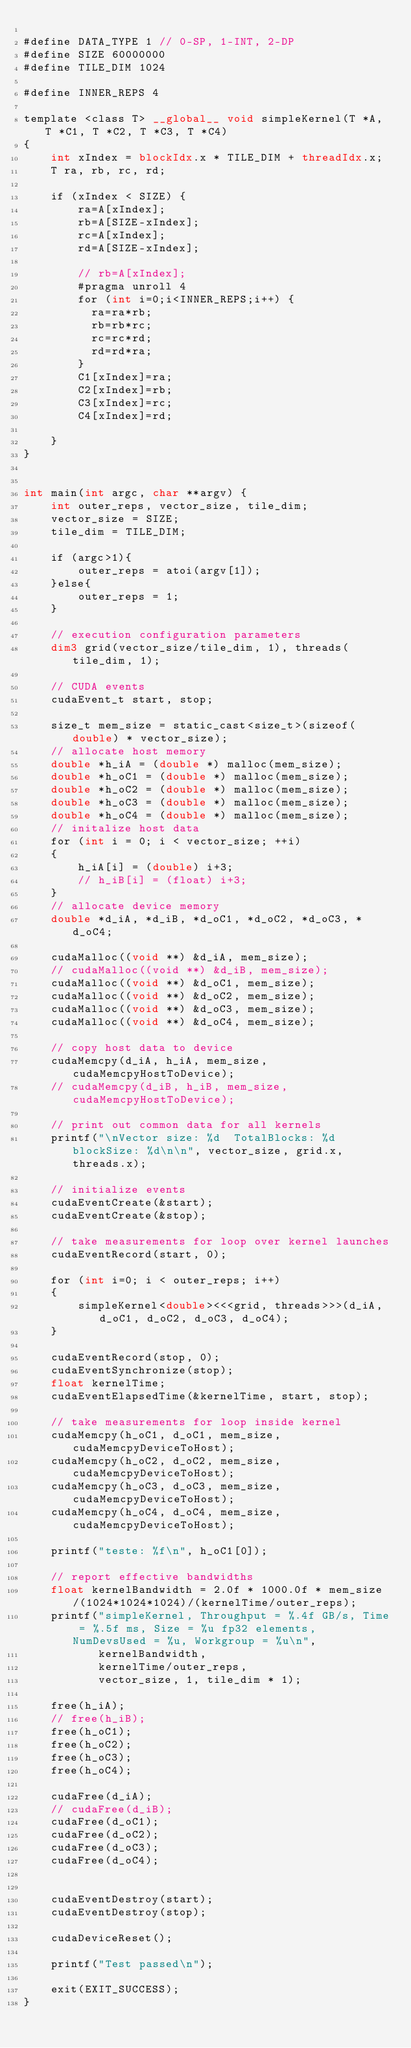<code> <loc_0><loc_0><loc_500><loc_500><_Cuda_>
#define DATA_TYPE 1 // 0-SP, 1-INT, 2-DP
#define SIZE 60000000
#define TILE_DIM 1024

#define INNER_REPS 4

template <class T> __global__ void simpleKernel(T *A, T *C1, T *C2, T *C3, T *C4)
{
    int xIndex = blockIdx.x * TILE_DIM + threadIdx.x;
    T ra, rb, rc, rd;

    if (xIndex < SIZE) {
        ra=A[xIndex];
        rb=A[SIZE-xIndex];
        rc=A[xIndex];
        rd=A[SIZE-xIndex];

        // rb=A[xIndex];
        #pragma unroll 4
        for (int i=0;i<INNER_REPS;i++) {
          ra=ra*rb;
          rb=rb*rc;
          rc=rc*rd;
          rd=rd*ra;
        }
        C1[xIndex]=ra;
        C2[xIndex]=rb;
        C3[xIndex]=rc;
        C4[xIndex]=rd;

    }
}


int main(int argc, char **argv) {
    int outer_reps, vector_size, tile_dim;
    vector_size = SIZE;
    tile_dim = TILE_DIM;

    if (argc>1){
        outer_reps = atoi(argv[1]);
    }else{
        outer_reps = 1;
    }

    // execution configuration parameters
    dim3 grid(vector_size/tile_dim, 1), threads(tile_dim, 1);

    // CUDA events
    cudaEvent_t start, stop;

    size_t mem_size = static_cast<size_t>(sizeof(double) * vector_size);
    // allocate host memory
    double *h_iA = (double *) malloc(mem_size);
    double *h_oC1 = (double *) malloc(mem_size);
    double *h_oC2 = (double *) malloc(mem_size);
    double *h_oC3 = (double *) malloc(mem_size);
    double *h_oC4 = (double *) malloc(mem_size);
    // initalize host data
    for (int i = 0; i < vector_size; ++i)
    {
        h_iA[i] = (double) i+3;
        // h_iB[i] = (float) i+3;
    }
    // allocate device memory
    double *d_iA, *d_iB, *d_oC1, *d_oC2, *d_oC3, *d_oC4;

    cudaMalloc((void **) &d_iA, mem_size);
    // cudaMalloc((void **) &d_iB, mem_size);
    cudaMalloc((void **) &d_oC1, mem_size);
    cudaMalloc((void **) &d_oC2, mem_size);
    cudaMalloc((void **) &d_oC3, mem_size);
    cudaMalloc((void **) &d_oC4, mem_size);

    // copy host data to device
    cudaMemcpy(d_iA, h_iA, mem_size, cudaMemcpyHostToDevice);
    // cudaMemcpy(d_iB, h_iB, mem_size, cudaMemcpyHostToDevice);

    // print out common data for all kernels
    printf("\nVector size: %d  TotalBlocks: %d blockSize: %d\n\n", vector_size, grid.x, threads.x);

    // initialize events
    cudaEventCreate(&start);
    cudaEventCreate(&stop);

    // take measurements for loop over kernel launches
    cudaEventRecord(start, 0);

    for (int i=0; i < outer_reps; i++)
    {
        simpleKernel<double><<<grid, threads>>>(d_iA, d_oC1, d_oC2, d_oC3, d_oC4);
    }

    cudaEventRecord(stop, 0);
    cudaEventSynchronize(stop);
    float kernelTime;
    cudaEventElapsedTime(&kernelTime, start, stop);

    // take measurements for loop inside kernel
    cudaMemcpy(h_oC1, d_oC1, mem_size, cudaMemcpyDeviceToHost);
    cudaMemcpy(h_oC2, d_oC2, mem_size, cudaMemcpyDeviceToHost);
    cudaMemcpy(h_oC3, d_oC3, mem_size, cudaMemcpyDeviceToHost);
    cudaMemcpy(h_oC4, d_oC4, mem_size, cudaMemcpyDeviceToHost);

    printf("teste: %f\n", h_oC1[0]);

    // report effective bandwidths
    float kernelBandwidth = 2.0f * 1000.0f * mem_size/(1024*1024*1024)/(kernelTime/outer_reps);
    printf("simpleKernel, Throughput = %.4f GB/s, Time = %.5f ms, Size = %u fp32 elements, NumDevsUsed = %u, Workgroup = %u\n",
           kernelBandwidth,
           kernelTime/outer_reps,
           vector_size, 1, tile_dim * 1);

    free(h_iA);
    // free(h_iB);
    free(h_oC1);
    free(h_oC2);
    free(h_oC3);
    free(h_oC4);

    cudaFree(d_iA);
    // cudaFree(d_iB);
    cudaFree(d_oC1);
    cudaFree(d_oC2);
    cudaFree(d_oC3);
    cudaFree(d_oC4);


    cudaEventDestroy(start);
    cudaEventDestroy(stop);

    cudaDeviceReset();

    printf("Test passed\n");

    exit(EXIT_SUCCESS);
}
</code> 